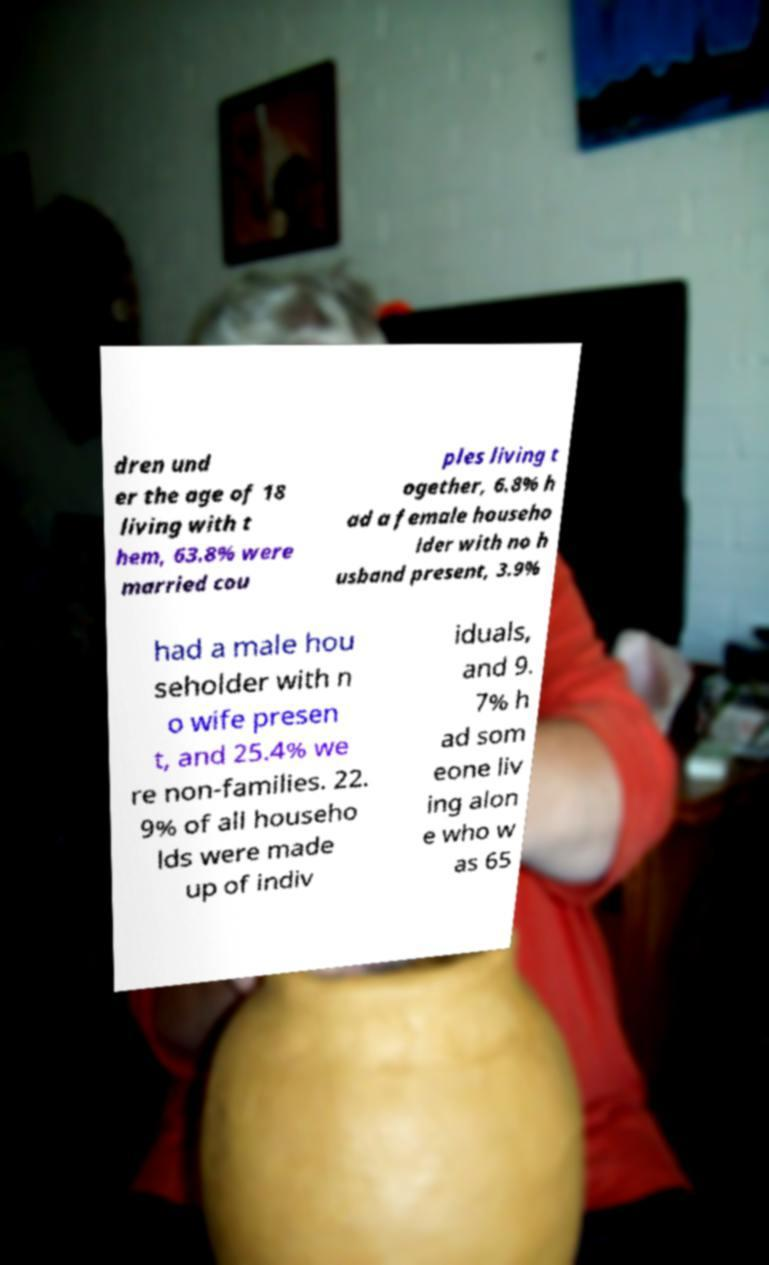Can you describe what's happening in the photo behind this piece of paper? The photo in the background appears to show a person, although the details are obscured by the piece of paper in the foreground. Due to the limited view, it's challenging to provide specific information about what's happening in the photo. 